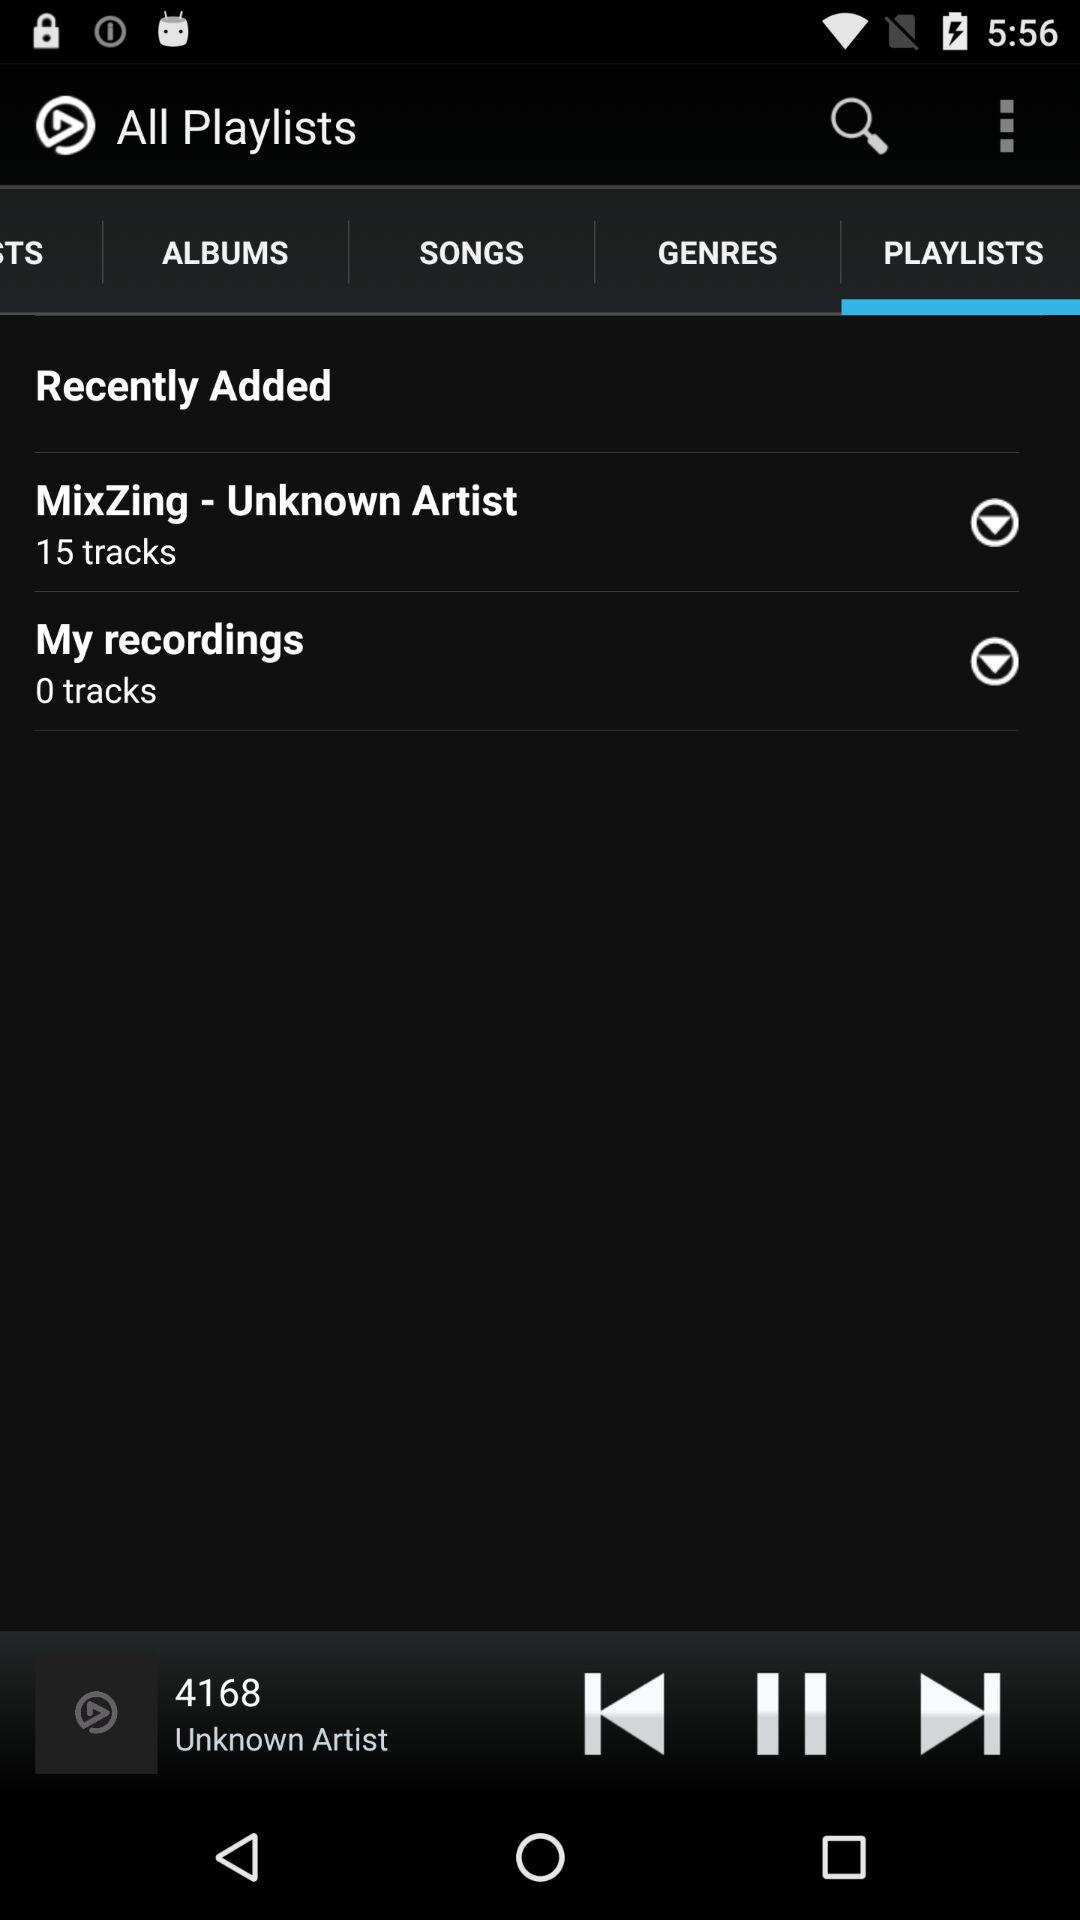Which tab is selected? The selected tab is Playlists. 